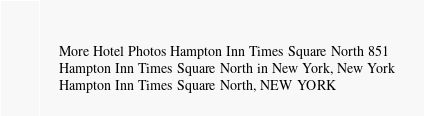Convert code to text. <code><loc_0><loc_0><loc_500><loc_500><_XML_>	  
	 More Hotel Photos Hampton Inn Times Square North 851 
	 Hampton Inn Times Square North in New York, New York 
	 Hampton Inn Times Square North, NEW YORK 
</code> 